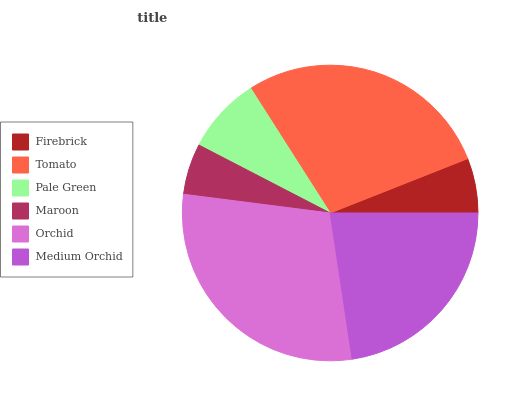Is Maroon the minimum?
Answer yes or no. Yes. Is Orchid the maximum?
Answer yes or no. Yes. Is Tomato the minimum?
Answer yes or no. No. Is Tomato the maximum?
Answer yes or no. No. Is Tomato greater than Firebrick?
Answer yes or no. Yes. Is Firebrick less than Tomato?
Answer yes or no. Yes. Is Firebrick greater than Tomato?
Answer yes or no. No. Is Tomato less than Firebrick?
Answer yes or no. No. Is Medium Orchid the high median?
Answer yes or no. Yes. Is Pale Green the low median?
Answer yes or no. Yes. Is Tomato the high median?
Answer yes or no. No. Is Firebrick the low median?
Answer yes or no. No. 